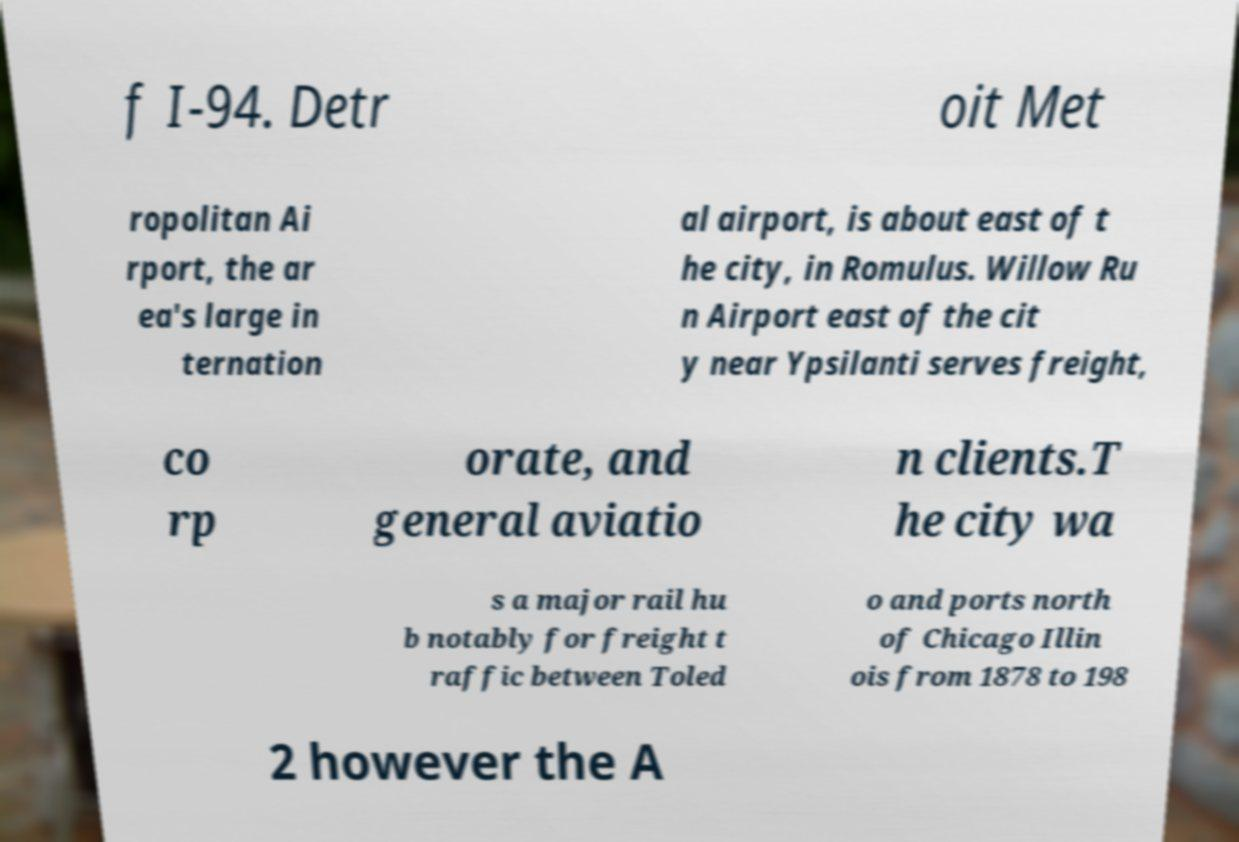Could you assist in decoding the text presented in this image and type it out clearly? f I-94. Detr oit Met ropolitan Ai rport, the ar ea's large in ternation al airport, is about east of t he city, in Romulus. Willow Ru n Airport east of the cit y near Ypsilanti serves freight, co rp orate, and general aviatio n clients.T he city wa s a major rail hu b notably for freight t raffic between Toled o and ports north of Chicago Illin ois from 1878 to 198 2 however the A 